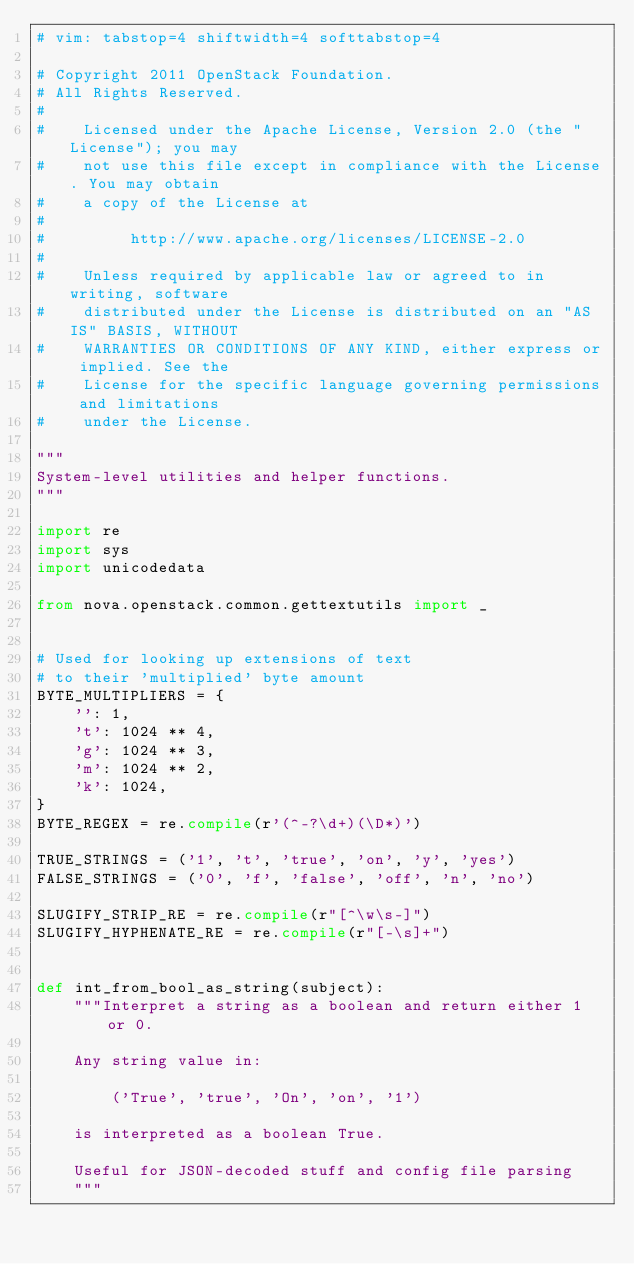Convert code to text. <code><loc_0><loc_0><loc_500><loc_500><_Python_># vim: tabstop=4 shiftwidth=4 softtabstop=4

# Copyright 2011 OpenStack Foundation.
# All Rights Reserved.
#
#    Licensed under the Apache License, Version 2.0 (the "License"); you may
#    not use this file except in compliance with the License. You may obtain
#    a copy of the License at
#
#         http://www.apache.org/licenses/LICENSE-2.0
#
#    Unless required by applicable law or agreed to in writing, software
#    distributed under the License is distributed on an "AS IS" BASIS, WITHOUT
#    WARRANTIES OR CONDITIONS OF ANY KIND, either express or implied. See the
#    License for the specific language governing permissions and limitations
#    under the License.

"""
System-level utilities and helper functions.
"""

import re
import sys
import unicodedata

from nova.openstack.common.gettextutils import _


# Used for looking up extensions of text
# to their 'multiplied' byte amount
BYTE_MULTIPLIERS = {
    '': 1,
    't': 1024 ** 4,
    'g': 1024 ** 3,
    'm': 1024 ** 2,
    'k': 1024,
}
BYTE_REGEX = re.compile(r'(^-?\d+)(\D*)')

TRUE_STRINGS = ('1', 't', 'true', 'on', 'y', 'yes')
FALSE_STRINGS = ('0', 'f', 'false', 'off', 'n', 'no')

SLUGIFY_STRIP_RE = re.compile(r"[^\w\s-]")
SLUGIFY_HYPHENATE_RE = re.compile(r"[-\s]+")


def int_from_bool_as_string(subject):
    """Interpret a string as a boolean and return either 1 or 0.

    Any string value in:

        ('True', 'true', 'On', 'on', '1')

    is interpreted as a boolean True.

    Useful for JSON-decoded stuff and config file parsing
    """</code> 